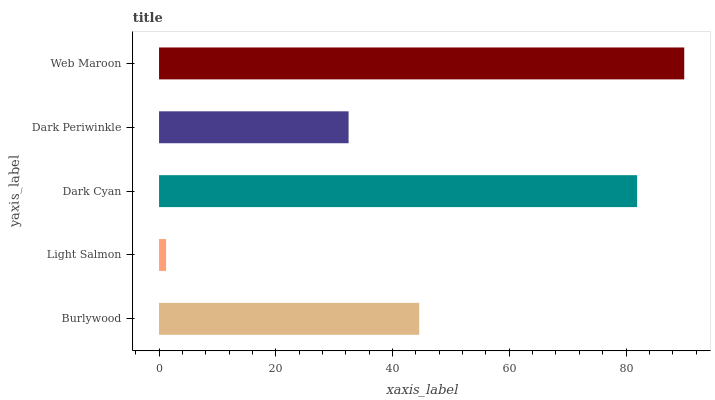Is Light Salmon the minimum?
Answer yes or no. Yes. Is Web Maroon the maximum?
Answer yes or no. Yes. Is Dark Cyan the minimum?
Answer yes or no. No. Is Dark Cyan the maximum?
Answer yes or no. No. Is Dark Cyan greater than Light Salmon?
Answer yes or no. Yes. Is Light Salmon less than Dark Cyan?
Answer yes or no. Yes. Is Light Salmon greater than Dark Cyan?
Answer yes or no. No. Is Dark Cyan less than Light Salmon?
Answer yes or no. No. Is Burlywood the high median?
Answer yes or no. Yes. Is Burlywood the low median?
Answer yes or no. Yes. Is Web Maroon the high median?
Answer yes or no. No. Is Dark Cyan the low median?
Answer yes or no. No. 